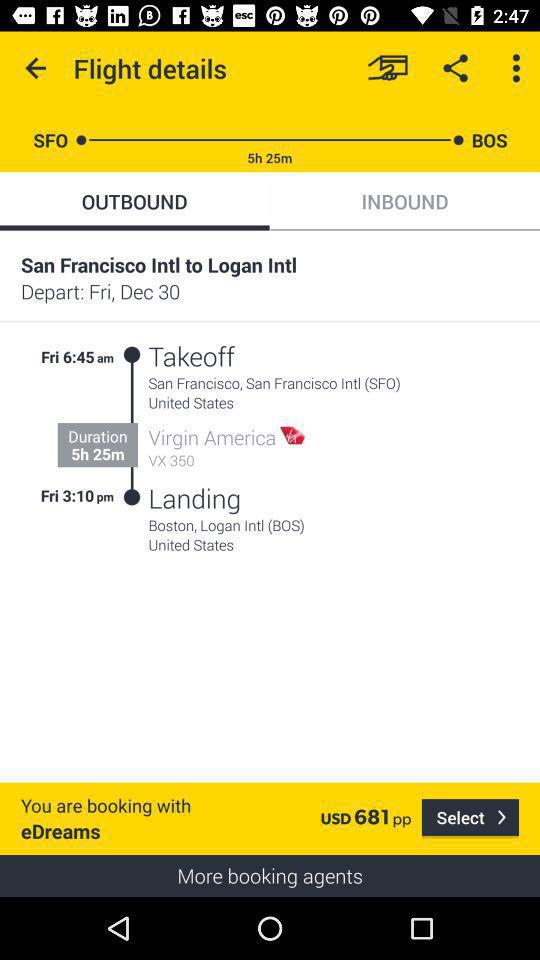What's the departure date? The departure date is Friday, December 30. 